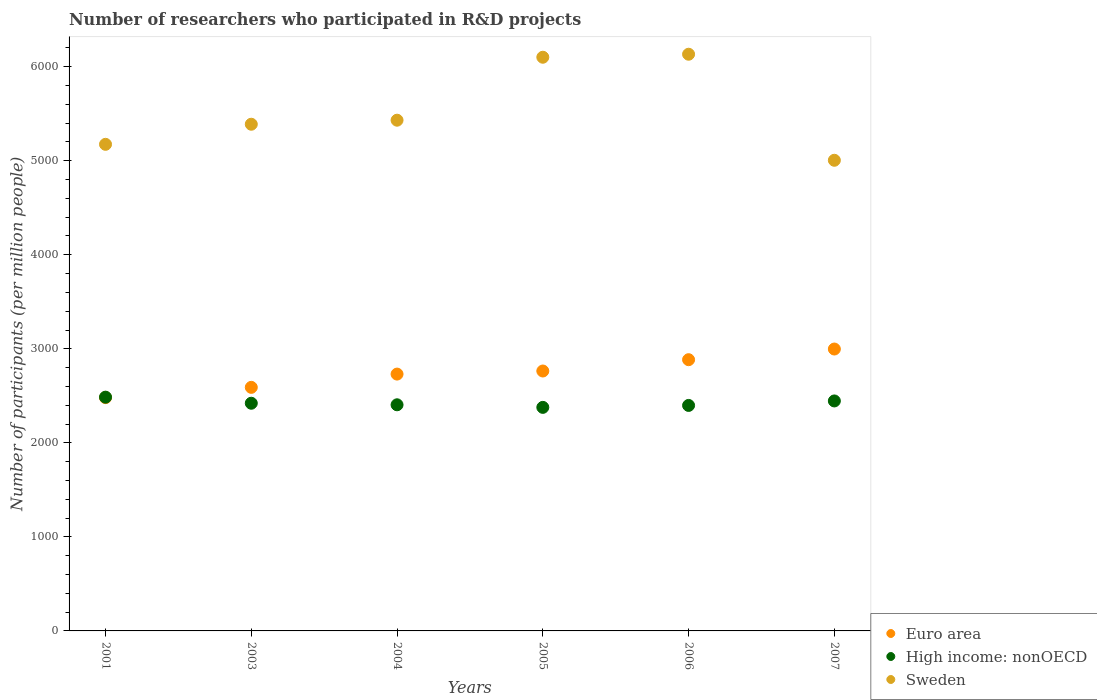How many different coloured dotlines are there?
Offer a very short reply. 3. Is the number of dotlines equal to the number of legend labels?
Keep it short and to the point. Yes. What is the number of researchers who participated in R&D projects in High income: nonOECD in 2006?
Provide a short and direct response. 2397.91. Across all years, what is the maximum number of researchers who participated in R&D projects in High income: nonOECD?
Provide a succinct answer. 2485.9. Across all years, what is the minimum number of researchers who participated in R&D projects in Euro area?
Keep it short and to the point. 2481.25. What is the total number of researchers who participated in R&D projects in Euro area in the graph?
Keep it short and to the point. 1.64e+04. What is the difference between the number of researchers who participated in R&D projects in Euro area in 2004 and that in 2007?
Give a very brief answer. -266.52. What is the difference between the number of researchers who participated in R&D projects in Euro area in 2003 and the number of researchers who participated in R&D projects in Sweden in 2007?
Your answer should be very brief. -2414.83. What is the average number of researchers who participated in R&D projects in Euro area per year?
Your answer should be compact. 2741.43. In the year 2003, what is the difference between the number of researchers who participated in R&D projects in High income: nonOECD and number of researchers who participated in R&D projects in Sweden?
Make the answer very short. -2966.95. In how many years, is the number of researchers who participated in R&D projects in Euro area greater than 2200?
Provide a succinct answer. 6. What is the ratio of the number of researchers who participated in R&D projects in High income: nonOECD in 2004 to that in 2006?
Provide a succinct answer. 1. What is the difference between the highest and the second highest number of researchers who participated in R&D projects in High income: nonOECD?
Your answer should be compact. 40.24. What is the difference between the highest and the lowest number of researchers who participated in R&D projects in Euro area?
Your answer should be compact. 516.44. Is the sum of the number of researchers who participated in R&D projects in Euro area in 2003 and 2007 greater than the maximum number of researchers who participated in R&D projects in Sweden across all years?
Your answer should be compact. No. Is it the case that in every year, the sum of the number of researchers who participated in R&D projects in High income: nonOECD and number of researchers who participated in R&D projects in Sweden  is greater than the number of researchers who participated in R&D projects in Euro area?
Provide a short and direct response. Yes. Does the number of researchers who participated in R&D projects in High income: nonOECD monotonically increase over the years?
Keep it short and to the point. No. Is the number of researchers who participated in R&D projects in High income: nonOECD strictly greater than the number of researchers who participated in R&D projects in Sweden over the years?
Provide a short and direct response. No. Is the number of researchers who participated in R&D projects in Sweden strictly less than the number of researchers who participated in R&D projects in Euro area over the years?
Give a very brief answer. No. How many years are there in the graph?
Provide a succinct answer. 6. What is the difference between two consecutive major ticks on the Y-axis?
Keep it short and to the point. 1000. Does the graph contain any zero values?
Make the answer very short. No. Where does the legend appear in the graph?
Provide a short and direct response. Bottom right. What is the title of the graph?
Make the answer very short. Number of researchers who participated in R&D projects. What is the label or title of the Y-axis?
Keep it short and to the point. Number of participants (per million people). What is the Number of participants (per million people) of Euro area in 2001?
Give a very brief answer. 2481.25. What is the Number of participants (per million people) of High income: nonOECD in 2001?
Keep it short and to the point. 2485.9. What is the Number of participants (per million people) in Sweden in 2001?
Offer a very short reply. 5174.6. What is the Number of participants (per million people) in Euro area in 2003?
Your answer should be compact. 2590.14. What is the Number of participants (per million people) in High income: nonOECD in 2003?
Offer a very short reply. 2421.22. What is the Number of participants (per million people) of Sweden in 2003?
Provide a short and direct response. 5388.17. What is the Number of participants (per million people) in Euro area in 2004?
Provide a succinct answer. 2731.18. What is the Number of participants (per million people) in High income: nonOECD in 2004?
Offer a terse response. 2404.69. What is the Number of participants (per million people) in Sweden in 2004?
Ensure brevity in your answer.  5431.14. What is the Number of participants (per million people) of Euro area in 2005?
Offer a terse response. 2763.98. What is the Number of participants (per million people) of High income: nonOECD in 2005?
Offer a terse response. 2377.3. What is the Number of participants (per million people) in Sweden in 2005?
Provide a short and direct response. 6100.67. What is the Number of participants (per million people) of Euro area in 2006?
Your response must be concise. 2884.31. What is the Number of participants (per million people) in High income: nonOECD in 2006?
Your answer should be very brief. 2397.91. What is the Number of participants (per million people) in Sweden in 2006?
Your response must be concise. 6132.66. What is the Number of participants (per million people) in Euro area in 2007?
Keep it short and to the point. 2997.7. What is the Number of participants (per million people) of High income: nonOECD in 2007?
Keep it short and to the point. 2445.66. What is the Number of participants (per million people) of Sweden in 2007?
Your answer should be very brief. 5004.96. Across all years, what is the maximum Number of participants (per million people) of Euro area?
Provide a short and direct response. 2997.7. Across all years, what is the maximum Number of participants (per million people) in High income: nonOECD?
Give a very brief answer. 2485.9. Across all years, what is the maximum Number of participants (per million people) of Sweden?
Your response must be concise. 6132.66. Across all years, what is the minimum Number of participants (per million people) in Euro area?
Your answer should be very brief. 2481.25. Across all years, what is the minimum Number of participants (per million people) of High income: nonOECD?
Provide a succinct answer. 2377.3. Across all years, what is the minimum Number of participants (per million people) in Sweden?
Your answer should be compact. 5004.96. What is the total Number of participants (per million people) in Euro area in the graph?
Your answer should be compact. 1.64e+04. What is the total Number of participants (per million people) of High income: nonOECD in the graph?
Offer a very short reply. 1.45e+04. What is the total Number of participants (per million people) of Sweden in the graph?
Provide a succinct answer. 3.32e+04. What is the difference between the Number of participants (per million people) of Euro area in 2001 and that in 2003?
Ensure brevity in your answer.  -108.88. What is the difference between the Number of participants (per million people) in High income: nonOECD in 2001 and that in 2003?
Offer a terse response. 64.68. What is the difference between the Number of participants (per million people) of Sweden in 2001 and that in 2003?
Your response must be concise. -213.57. What is the difference between the Number of participants (per million people) in Euro area in 2001 and that in 2004?
Provide a succinct answer. -249.93. What is the difference between the Number of participants (per million people) in High income: nonOECD in 2001 and that in 2004?
Keep it short and to the point. 81.21. What is the difference between the Number of participants (per million people) of Sweden in 2001 and that in 2004?
Ensure brevity in your answer.  -256.53. What is the difference between the Number of participants (per million people) of Euro area in 2001 and that in 2005?
Offer a terse response. -282.73. What is the difference between the Number of participants (per million people) in High income: nonOECD in 2001 and that in 2005?
Give a very brief answer. 108.6. What is the difference between the Number of participants (per million people) of Sweden in 2001 and that in 2005?
Make the answer very short. -926.06. What is the difference between the Number of participants (per million people) in Euro area in 2001 and that in 2006?
Your answer should be very brief. -403.06. What is the difference between the Number of participants (per million people) in High income: nonOECD in 2001 and that in 2006?
Make the answer very short. 87.99. What is the difference between the Number of participants (per million people) in Sweden in 2001 and that in 2006?
Your answer should be very brief. -958.05. What is the difference between the Number of participants (per million people) of Euro area in 2001 and that in 2007?
Give a very brief answer. -516.44. What is the difference between the Number of participants (per million people) in High income: nonOECD in 2001 and that in 2007?
Make the answer very short. 40.24. What is the difference between the Number of participants (per million people) in Sweden in 2001 and that in 2007?
Provide a short and direct response. 169.64. What is the difference between the Number of participants (per million people) of Euro area in 2003 and that in 2004?
Your response must be concise. -141.05. What is the difference between the Number of participants (per million people) in High income: nonOECD in 2003 and that in 2004?
Give a very brief answer. 16.53. What is the difference between the Number of participants (per million people) in Sweden in 2003 and that in 2004?
Provide a succinct answer. -42.97. What is the difference between the Number of participants (per million people) of Euro area in 2003 and that in 2005?
Offer a very short reply. -173.85. What is the difference between the Number of participants (per million people) of High income: nonOECD in 2003 and that in 2005?
Provide a short and direct response. 43.92. What is the difference between the Number of participants (per million people) of Sweden in 2003 and that in 2005?
Your answer should be compact. -712.5. What is the difference between the Number of participants (per million people) in Euro area in 2003 and that in 2006?
Give a very brief answer. -294.17. What is the difference between the Number of participants (per million people) of High income: nonOECD in 2003 and that in 2006?
Your answer should be very brief. 23.31. What is the difference between the Number of participants (per million people) of Sweden in 2003 and that in 2006?
Provide a succinct answer. -744.49. What is the difference between the Number of participants (per million people) in Euro area in 2003 and that in 2007?
Ensure brevity in your answer.  -407.56. What is the difference between the Number of participants (per million people) of High income: nonOECD in 2003 and that in 2007?
Provide a short and direct response. -24.44. What is the difference between the Number of participants (per million people) in Sweden in 2003 and that in 2007?
Provide a succinct answer. 383.21. What is the difference between the Number of participants (per million people) in Euro area in 2004 and that in 2005?
Provide a succinct answer. -32.8. What is the difference between the Number of participants (per million people) in High income: nonOECD in 2004 and that in 2005?
Keep it short and to the point. 27.39. What is the difference between the Number of participants (per million people) in Sweden in 2004 and that in 2005?
Your answer should be very brief. -669.53. What is the difference between the Number of participants (per million people) in Euro area in 2004 and that in 2006?
Your answer should be compact. -153.13. What is the difference between the Number of participants (per million people) of High income: nonOECD in 2004 and that in 2006?
Provide a short and direct response. 6.78. What is the difference between the Number of participants (per million people) of Sweden in 2004 and that in 2006?
Keep it short and to the point. -701.52. What is the difference between the Number of participants (per million people) in Euro area in 2004 and that in 2007?
Your answer should be very brief. -266.52. What is the difference between the Number of participants (per million people) of High income: nonOECD in 2004 and that in 2007?
Give a very brief answer. -40.97. What is the difference between the Number of participants (per million people) of Sweden in 2004 and that in 2007?
Provide a succinct answer. 426.17. What is the difference between the Number of participants (per million people) of Euro area in 2005 and that in 2006?
Your answer should be compact. -120.33. What is the difference between the Number of participants (per million people) in High income: nonOECD in 2005 and that in 2006?
Give a very brief answer. -20.62. What is the difference between the Number of participants (per million people) of Sweden in 2005 and that in 2006?
Provide a short and direct response. -31.99. What is the difference between the Number of participants (per million people) in Euro area in 2005 and that in 2007?
Offer a terse response. -233.72. What is the difference between the Number of participants (per million people) in High income: nonOECD in 2005 and that in 2007?
Offer a very short reply. -68.36. What is the difference between the Number of participants (per million people) of Sweden in 2005 and that in 2007?
Ensure brevity in your answer.  1095.7. What is the difference between the Number of participants (per million people) in Euro area in 2006 and that in 2007?
Offer a very short reply. -113.39. What is the difference between the Number of participants (per million people) in High income: nonOECD in 2006 and that in 2007?
Give a very brief answer. -47.75. What is the difference between the Number of participants (per million people) of Sweden in 2006 and that in 2007?
Provide a succinct answer. 1127.7. What is the difference between the Number of participants (per million people) in Euro area in 2001 and the Number of participants (per million people) in High income: nonOECD in 2003?
Make the answer very short. 60.03. What is the difference between the Number of participants (per million people) of Euro area in 2001 and the Number of participants (per million people) of Sweden in 2003?
Make the answer very short. -2906.92. What is the difference between the Number of participants (per million people) of High income: nonOECD in 2001 and the Number of participants (per million people) of Sweden in 2003?
Offer a terse response. -2902.27. What is the difference between the Number of participants (per million people) in Euro area in 2001 and the Number of participants (per million people) in High income: nonOECD in 2004?
Provide a succinct answer. 76.56. What is the difference between the Number of participants (per million people) in Euro area in 2001 and the Number of participants (per million people) in Sweden in 2004?
Ensure brevity in your answer.  -2949.88. What is the difference between the Number of participants (per million people) in High income: nonOECD in 2001 and the Number of participants (per million people) in Sweden in 2004?
Offer a very short reply. -2945.23. What is the difference between the Number of participants (per million people) of Euro area in 2001 and the Number of participants (per million people) of High income: nonOECD in 2005?
Offer a terse response. 103.95. What is the difference between the Number of participants (per million people) in Euro area in 2001 and the Number of participants (per million people) in Sweden in 2005?
Offer a terse response. -3619.41. What is the difference between the Number of participants (per million people) of High income: nonOECD in 2001 and the Number of participants (per million people) of Sweden in 2005?
Ensure brevity in your answer.  -3614.76. What is the difference between the Number of participants (per million people) of Euro area in 2001 and the Number of participants (per million people) of High income: nonOECD in 2006?
Provide a short and direct response. 83.34. What is the difference between the Number of participants (per million people) in Euro area in 2001 and the Number of participants (per million people) in Sweden in 2006?
Your response must be concise. -3651.41. What is the difference between the Number of participants (per million people) of High income: nonOECD in 2001 and the Number of participants (per million people) of Sweden in 2006?
Ensure brevity in your answer.  -3646.76. What is the difference between the Number of participants (per million people) of Euro area in 2001 and the Number of participants (per million people) of High income: nonOECD in 2007?
Keep it short and to the point. 35.59. What is the difference between the Number of participants (per million people) of Euro area in 2001 and the Number of participants (per million people) of Sweden in 2007?
Your response must be concise. -2523.71. What is the difference between the Number of participants (per million people) in High income: nonOECD in 2001 and the Number of participants (per million people) in Sweden in 2007?
Make the answer very short. -2519.06. What is the difference between the Number of participants (per million people) of Euro area in 2003 and the Number of participants (per million people) of High income: nonOECD in 2004?
Your answer should be very brief. 185.44. What is the difference between the Number of participants (per million people) in Euro area in 2003 and the Number of participants (per million people) in Sweden in 2004?
Provide a succinct answer. -2841. What is the difference between the Number of participants (per million people) in High income: nonOECD in 2003 and the Number of participants (per million people) in Sweden in 2004?
Your answer should be compact. -3009.91. What is the difference between the Number of participants (per million people) of Euro area in 2003 and the Number of participants (per million people) of High income: nonOECD in 2005?
Ensure brevity in your answer.  212.84. What is the difference between the Number of participants (per million people) in Euro area in 2003 and the Number of participants (per million people) in Sweden in 2005?
Your response must be concise. -3510.53. What is the difference between the Number of participants (per million people) in High income: nonOECD in 2003 and the Number of participants (per million people) in Sweden in 2005?
Your answer should be compact. -3679.44. What is the difference between the Number of participants (per million people) in Euro area in 2003 and the Number of participants (per million people) in High income: nonOECD in 2006?
Your answer should be compact. 192.22. What is the difference between the Number of participants (per million people) in Euro area in 2003 and the Number of participants (per million people) in Sweden in 2006?
Your response must be concise. -3542.52. What is the difference between the Number of participants (per million people) of High income: nonOECD in 2003 and the Number of participants (per million people) of Sweden in 2006?
Your answer should be very brief. -3711.44. What is the difference between the Number of participants (per million people) in Euro area in 2003 and the Number of participants (per million people) in High income: nonOECD in 2007?
Your answer should be very brief. 144.47. What is the difference between the Number of participants (per million people) of Euro area in 2003 and the Number of participants (per million people) of Sweden in 2007?
Offer a very short reply. -2414.83. What is the difference between the Number of participants (per million people) of High income: nonOECD in 2003 and the Number of participants (per million people) of Sweden in 2007?
Your response must be concise. -2583.74. What is the difference between the Number of participants (per million people) of Euro area in 2004 and the Number of participants (per million people) of High income: nonOECD in 2005?
Provide a short and direct response. 353.88. What is the difference between the Number of participants (per million people) of Euro area in 2004 and the Number of participants (per million people) of Sweden in 2005?
Keep it short and to the point. -3369.48. What is the difference between the Number of participants (per million people) in High income: nonOECD in 2004 and the Number of participants (per million people) in Sweden in 2005?
Your answer should be compact. -3695.97. What is the difference between the Number of participants (per million people) in Euro area in 2004 and the Number of participants (per million people) in High income: nonOECD in 2006?
Ensure brevity in your answer.  333.27. What is the difference between the Number of participants (per million people) in Euro area in 2004 and the Number of participants (per million people) in Sweden in 2006?
Offer a terse response. -3401.48. What is the difference between the Number of participants (per million people) in High income: nonOECD in 2004 and the Number of participants (per million people) in Sweden in 2006?
Offer a very short reply. -3727.96. What is the difference between the Number of participants (per million people) of Euro area in 2004 and the Number of participants (per million people) of High income: nonOECD in 2007?
Make the answer very short. 285.52. What is the difference between the Number of participants (per million people) in Euro area in 2004 and the Number of participants (per million people) in Sweden in 2007?
Give a very brief answer. -2273.78. What is the difference between the Number of participants (per million people) of High income: nonOECD in 2004 and the Number of participants (per million people) of Sweden in 2007?
Offer a terse response. -2600.27. What is the difference between the Number of participants (per million people) in Euro area in 2005 and the Number of participants (per million people) in High income: nonOECD in 2006?
Offer a very short reply. 366.07. What is the difference between the Number of participants (per million people) in Euro area in 2005 and the Number of participants (per million people) in Sweden in 2006?
Your answer should be compact. -3368.68. What is the difference between the Number of participants (per million people) of High income: nonOECD in 2005 and the Number of participants (per million people) of Sweden in 2006?
Your answer should be very brief. -3755.36. What is the difference between the Number of participants (per million people) in Euro area in 2005 and the Number of participants (per million people) in High income: nonOECD in 2007?
Keep it short and to the point. 318.32. What is the difference between the Number of participants (per million people) of Euro area in 2005 and the Number of participants (per million people) of Sweden in 2007?
Your answer should be compact. -2240.98. What is the difference between the Number of participants (per million people) in High income: nonOECD in 2005 and the Number of participants (per million people) in Sweden in 2007?
Offer a terse response. -2627.66. What is the difference between the Number of participants (per million people) in Euro area in 2006 and the Number of participants (per million people) in High income: nonOECD in 2007?
Offer a very short reply. 438.65. What is the difference between the Number of participants (per million people) in Euro area in 2006 and the Number of participants (per million people) in Sweden in 2007?
Make the answer very short. -2120.65. What is the difference between the Number of participants (per million people) in High income: nonOECD in 2006 and the Number of participants (per million people) in Sweden in 2007?
Your response must be concise. -2607.05. What is the average Number of participants (per million people) of Euro area per year?
Give a very brief answer. 2741.43. What is the average Number of participants (per million people) of High income: nonOECD per year?
Provide a short and direct response. 2422.12. What is the average Number of participants (per million people) of Sweden per year?
Keep it short and to the point. 5538.7. In the year 2001, what is the difference between the Number of participants (per million people) of Euro area and Number of participants (per million people) of High income: nonOECD?
Offer a terse response. -4.65. In the year 2001, what is the difference between the Number of participants (per million people) of Euro area and Number of participants (per million people) of Sweden?
Offer a very short reply. -2693.35. In the year 2001, what is the difference between the Number of participants (per million people) in High income: nonOECD and Number of participants (per million people) in Sweden?
Your answer should be compact. -2688.7. In the year 2003, what is the difference between the Number of participants (per million people) in Euro area and Number of participants (per million people) in High income: nonOECD?
Make the answer very short. 168.91. In the year 2003, what is the difference between the Number of participants (per million people) of Euro area and Number of participants (per million people) of Sweden?
Offer a very short reply. -2798.03. In the year 2003, what is the difference between the Number of participants (per million people) of High income: nonOECD and Number of participants (per million people) of Sweden?
Your response must be concise. -2966.95. In the year 2004, what is the difference between the Number of participants (per million people) of Euro area and Number of participants (per million people) of High income: nonOECD?
Your response must be concise. 326.49. In the year 2004, what is the difference between the Number of participants (per million people) of Euro area and Number of participants (per million people) of Sweden?
Give a very brief answer. -2699.96. In the year 2004, what is the difference between the Number of participants (per million people) of High income: nonOECD and Number of participants (per million people) of Sweden?
Keep it short and to the point. -3026.44. In the year 2005, what is the difference between the Number of participants (per million people) of Euro area and Number of participants (per million people) of High income: nonOECD?
Your answer should be compact. 386.68. In the year 2005, what is the difference between the Number of participants (per million people) of Euro area and Number of participants (per million people) of Sweden?
Offer a very short reply. -3336.68. In the year 2005, what is the difference between the Number of participants (per million people) in High income: nonOECD and Number of participants (per million people) in Sweden?
Provide a short and direct response. -3723.37. In the year 2006, what is the difference between the Number of participants (per million people) of Euro area and Number of participants (per million people) of High income: nonOECD?
Your response must be concise. 486.39. In the year 2006, what is the difference between the Number of participants (per million people) of Euro area and Number of participants (per million people) of Sweden?
Your answer should be very brief. -3248.35. In the year 2006, what is the difference between the Number of participants (per million people) of High income: nonOECD and Number of participants (per million people) of Sweden?
Provide a succinct answer. -3734.74. In the year 2007, what is the difference between the Number of participants (per million people) in Euro area and Number of participants (per million people) in High income: nonOECD?
Offer a very short reply. 552.03. In the year 2007, what is the difference between the Number of participants (per million people) in Euro area and Number of participants (per million people) in Sweden?
Offer a very short reply. -2007.27. In the year 2007, what is the difference between the Number of participants (per million people) of High income: nonOECD and Number of participants (per million people) of Sweden?
Keep it short and to the point. -2559.3. What is the ratio of the Number of participants (per million people) of Euro area in 2001 to that in 2003?
Give a very brief answer. 0.96. What is the ratio of the Number of participants (per million people) in High income: nonOECD in 2001 to that in 2003?
Offer a terse response. 1.03. What is the ratio of the Number of participants (per million people) in Sweden in 2001 to that in 2003?
Provide a succinct answer. 0.96. What is the ratio of the Number of participants (per million people) in Euro area in 2001 to that in 2004?
Make the answer very short. 0.91. What is the ratio of the Number of participants (per million people) of High income: nonOECD in 2001 to that in 2004?
Offer a very short reply. 1.03. What is the ratio of the Number of participants (per million people) in Sweden in 2001 to that in 2004?
Your answer should be compact. 0.95. What is the ratio of the Number of participants (per million people) of Euro area in 2001 to that in 2005?
Your answer should be compact. 0.9. What is the ratio of the Number of participants (per million people) of High income: nonOECD in 2001 to that in 2005?
Keep it short and to the point. 1.05. What is the ratio of the Number of participants (per million people) in Sweden in 2001 to that in 2005?
Your response must be concise. 0.85. What is the ratio of the Number of participants (per million people) of Euro area in 2001 to that in 2006?
Ensure brevity in your answer.  0.86. What is the ratio of the Number of participants (per million people) of High income: nonOECD in 2001 to that in 2006?
Offer a terse response. 1.04. What is the ratio of the Number of participants (per million people) of Sweden in 2001 to that in 2006?
Offer a terse response. 0.84. What is the ratio of the Number of participants (per million people) in Euro area in 2001 to that in 2007?
Your answer should be compact. 0.83. What is the ratio of the Number of participants (per million people) of High income: nonOECD in 2001 to that in 2007?
Your answer should be compact. 1.02. What is the ratio of the Number of participants (per million people) in Sweden in 2001 to that in 2007?
Keep it short and to the point. 1.03. What is the ratio of the Number of participants (per million people) of Euro area in 2003 to that in 2004?
Keep it short and to the point. 0.95. What is the ratio of the Number of participants (per million people) in High income: nonOECD in 2003 to that in 2004?
Ensure brevity in your answer.  1.01. What is the ratio of the Number of participants (per million people) of Sweden in 2003 to that in 2004?
Your response must be concise. 0.99. What is the ratio of the Number of participants (per million people) in Euro area in 2003 to that in 2005?
Provide a succinct answer. 0.94. What is the ratio of the Number of participants (per million people) in High income: nonOECD in 2003 to that in 2005?
Give a very brief answer. 1.02. What is the ratio of the Number of participants (per million people) of Sweden in 2003 to that in 2005?
Give a very brief answer. 0.88. What is the ratio of the Number of participants (per million people) in Euro area in 2003 to that in 2006?
Offer a terse response. 0.9. What is the ratio of the Number of participants (per million people) in High income: nonOECD in 2003 to that in 2006?
Keep it short and to the point. 1.01. What is the ratio of the Number of participants (per million people) in Sweden in 2003 to that in 2006?
Ensure brevity in your answer.  0.88. What is the ratio of the Number of participants (per million people) in Euro area in 2003 to that in 2007?
Ensure brevity in your answer.  0.86. What is the ratio of the Number of participants (per million people) in Sweden in 2003 to that in 2007?
Your answer should be very brief. 1.08. What is the ratio of the Number of participants (per million people) in High income: nonOECD in 2004 to that in 2005?
Give a very brief answer. 1.01. What is the ratio of the Number of participants (per million people) of Sweden in 2004 to that in 2005?
Provide a succinct answer. 0.89. What is the ratio of the Number of participants (per million people) in Euro area in 2004 to that in 2006?
Make the answer very short. 0.95. What is the ratio of the Number of participants (per million people) of High income: nonOECD in 2004 to that in 2006?
Your response must be concise. 1. What is the ratio of the Number of participants (per million people) of Sweden in 2004 to that in 2006?
Ensure brevity in your answer.  0.89. What is the ratio of the Number of participants (per million people) of Euro area in 2004 to that in 2007?
Give a very brief answer. 0.91. What is the ratio of the Number of participants (per million people) of High income: nonOECD in 2004 to that in 2007?
Your answer should be compact. 0.98. What is the ratio of the Number of participants (per million people) of Sweden in 2004 to that in 2007?
Offer a very short reply. 1.09. What is the ratio of the Number of participants (per million people) of Euro area in 2005 to that in 2006?
Keep it short and to the point. 0.96. What is the ratio of the Number of participants (per million people) in Sweden in 2005 to that in 2006?
Provide a succinct answer. 0.99. What is the ratio of the Number of participants (per million people) of Euro area in 2005 to that in 2007?
Make the answer very short. 0.92. What is the ratio of the Number of participants (per million people) of Sweden in 2005 to that in 2007?
Keep it short and to the point. 1.22. What is the ratio of the Number of participants (per million people) of Euro area in 2006 to that in 2007?
Your answer should be compact. 0.96. What is the ratio of the Number of participants (per million people) of High income: nonOECD in 2006 to that in 2007?
Offer a very short reply. 0.98. What is the ratio of the Number of participants (per million people) in Sweden in 2006 to that in 2007?
Provide a short and direct response. 1.23. What is the difference between the highest and the second highest Number of participants (per million people) in Euro area?
Give a very brief answer. 113.39. What is the difference between the highest and the second highest Number of participants (per million people) of High income: nonOECD?
Keep it short and to the point. 40.24. What is the difference between the highest and the second highest Number of participants (per million people) of Sweden?
Ensure brevity in your answer.  31.99. What is the difference between the highest and the lowest Number of participants (per million people) in Euro area?
Provide a succinct answer. 516.44. What is the difference between the highest and the lowest Number of participants (per million people) in High income: nonOECD?
Your answer should be compact. 108.6. What is the difference between the highest and the lowest Number of participants (per million people) in Sweden?
Ensure brevity in your answer.  1127.7. 